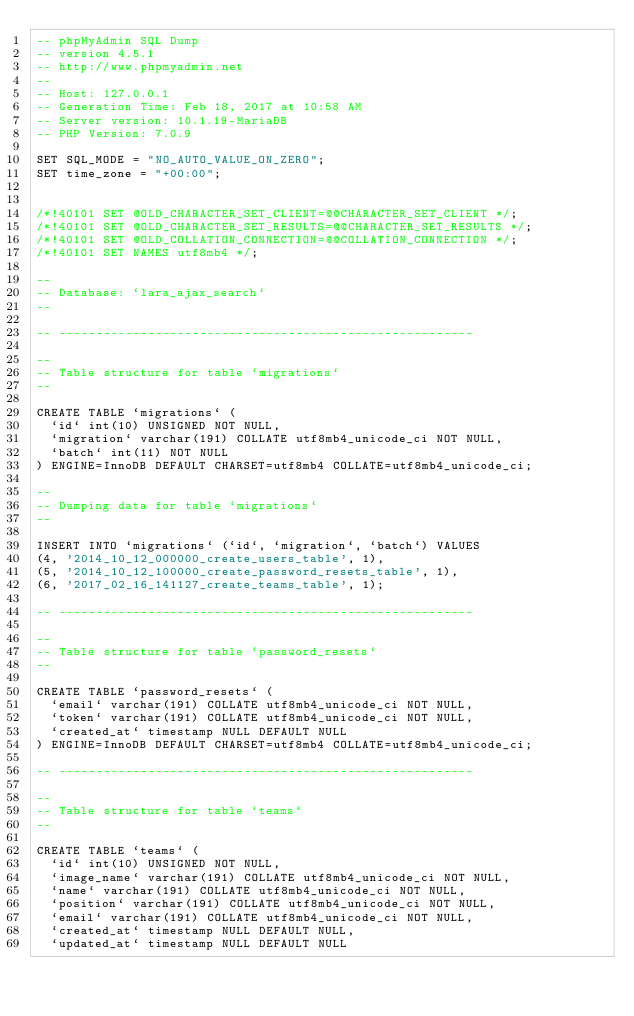<code> <loc_0><loc_0><loc_500><loc_500><_SQL_>-- phpMyAdmin SQL Dump
-- version 4.5.1
-- http://www.phpmyadmin.net
--
-- Host: 127.0.0.1
-- Generation Time: Feb 18, 2017 at 10:58 AM
-- Server version: 10.1.19-MariaDB
-- PHP Version: 7.0.9

SET SQL_MODE = "NO_AUTO_VALUE_ON_ZERO";
SET time_zone = "+00:00";


/*!40101 SET @OLD_CHARACTER_SET_CLIENT=@@CHARACTER_SET_CLIENT */;
/*!40101 SET @OLD_CHARACTER_SET_RESULTS=@@CHARACTER_SET_RESULTS */;
/*!40101 SET @OLD_COLLATION_CONNECTION=@@COLLATION_CONNECTION */;
/*!40101 SET NAMES utf8mb4 */;

--
-- Database: `lara_ajax_search`
--

-- --------------------------------------------------------

--
-- Table structure for table `migrations`
--

CREATE TABLE `migrations` (
  `id` int(10) UNSIGNED NOT NULL,
  `migration` varchar(191) COLLATE utf8mb4_unicode_ci NOT NULL,
  `batch` int(11) NOT NULL
) ENGINE=InnoDB DEFAULT CHARSET=utf8mb4 COLLATE=utf8mb4_unicode_ci;

--
-- Dumping data for table `migrations`
--

INSERT INTO `migrations` (`id`, `migration`, `batch`) VALUES
(4, '2014_10_12_000000_create_users_table', 1),
(5, '2014_10_12_100000_create_password_resets_table', 1),
(6, '2017_02_16_141127_create_teams_table', 1);

-- --------------------------------------------------------

--
-- Table structure for table `password_resets`
--

CREATE TABLE `password_resets` (
  `email` varchar(191) COLLATE utf8mb4_unicode_ci NOT NULL,
  `token` varchar(191) COLLATE utf8mb4_unicode_ci NOT NULL,
  `created_at` timestamp NULL DEFAULT NULL
) ENGINE=InnoDB DEFAULT CHARSET=utf8mb4 COLLATE=utf8mb4_unicode_ci;

-- --------------------------------------------------------

--
-- Table structure for table `teams`
--

CREATE TABLE `teams` (
  `id` int(10) UNSIGNED NOT NULL,
  `image_name` varchar(191) COLLATE utf8mb4_unicode_ci NOT NULL,
  `name` varchar(191) COLLATE utf8mb4_unicode_ci NOT NULL,
  `position` varchar(191) COLLATE utf8mb4_unicode_ci NOT NULL,
  `email` varchar(191) COLLATE utf8mb4_unicode_ci NOT NULL,
  `created_at` timestamp NULL DEFAULT NULL,
  `updated_at` timestamp NULL DEFAULT NULL</code> 